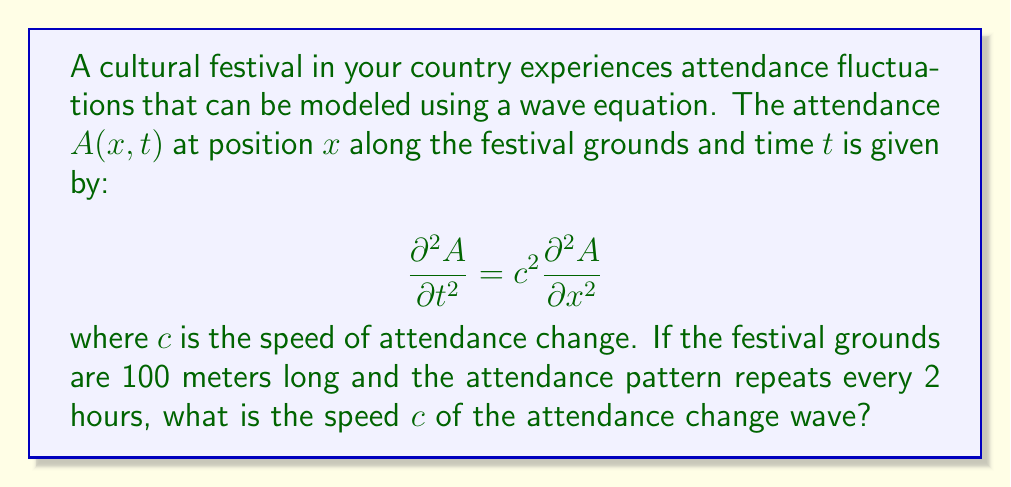Teach me how to tackle this problem. To solve this problem, we'll follow these steps:

1) The general solution for a wave equation is of the form:
   $$A(x,t) = f(x - ct) + g(x + ct)$$

2) Given the periodic nature of the festival, we can assume a standing wave solution:
   $$A(x,t) = \sin(kx)\cos(\omega t)$$

3) The wave number $k$ and angular frequency $\omega$ are related to the wavelength $\lambda$ and period $T$ respectively:
   $$k = \frac{2\pi}{\lambda}, \quad \omega = \frac{2\pi}{T}$$

4) The festival grounds length $L = 100$ m corresponds to half a wavelength:
   $$L = \frac{\lambda}{2} \implies \lambda = 200 \text{ m}$$

5) The period $T$ is given as 2 hours:
   $$T = 2 \text{ hours} = 7200 \text{ seconds}$$

6) Now we can calculate $k$ and $\omega$:
   $$k = \frac{2\pi}{200} = \frac{\pi}{100} \text{ m}^{-1}$$
   $$\omega = \frac{2\pi}{7200} = \frac{\pi}{3600} \text{ s}^{-1}$$

7) For a wave equation, the speed $c$ is related to $k$ and $\omega$ by:
   $$c = \frac{\omega}{k}$$

8) Substituting the values:
   $$c = \frac{\pi/3600}{\pi/100} = \frac{100}{3600} = \frac{1}{36} \text{ m/s}$$

Therefore, the speed of the attendance change wave is $\frac{1}{36}$ m/s.
Answer: $\frac{1}{36}$ m/s 